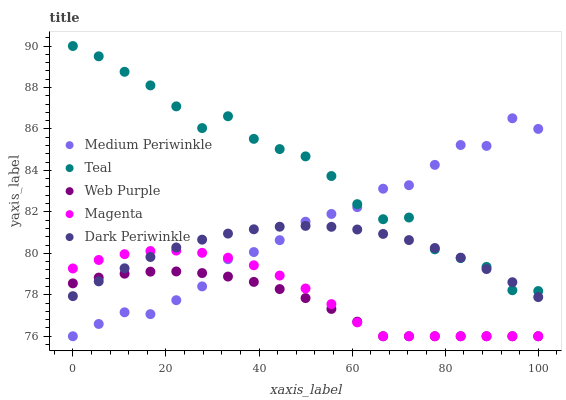Does Web Purple have the minimum area under the curve?
Answer yes or no. Yes. Does Teal have the maximum area under the curve?
Answer yes or no. Yes. Does Medium Periwinkle have the minimum area under the curve?
Answer yes or no. No. Does Medium Periwinkle have the maximum area under the curve?
Answer yes or no. No. Is Dark Periwinkle the smoothest?
Answer yes or no. Yes. Is Teal the roughest?
Answer yes or no. Yes. Is Medium Periwinkle the smoothest?
Answer yes or no. No. Is Medium Periwinkle the roughest?
Answer yes or no. No. Does Web Purple have the lowest value?
Answer yes or no. Yes. Does Teal have the lowest value?
Answer yes or no. No. Does Teal have the highest value?
Answer yes or no. Yes. Does Medium Periwinkle have the highest value?
Answer yes or no. No. Is Magenta less than Teal?
Answer yes or no. Yes. Is Teal greater than Web Purple?
Answer yes or no. Yes. Does Magenta intersect Dark Periwinkle?
Answer yes or no. Yes. Is Magenta less than Dark Periwinkle?
Answer yes or no. No. Is Magenta greater than Dark Periwinkle?
Answer yes or no. No. Does Magenta intersect Teal?
Answer yes or no. No. 